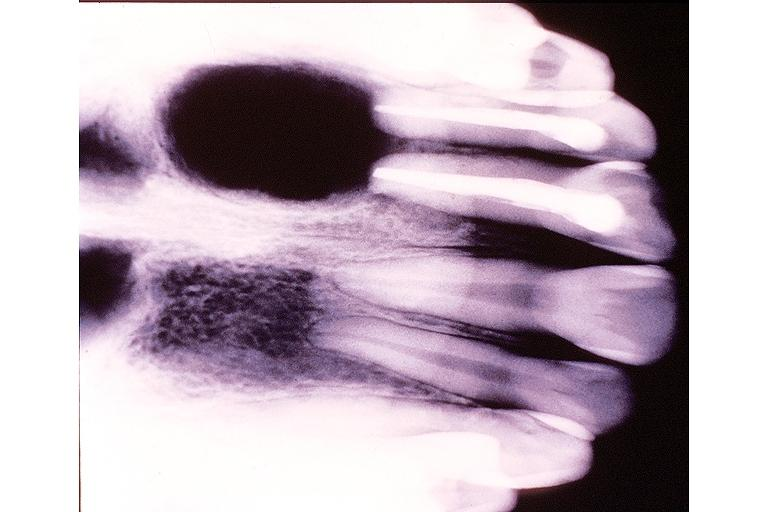s lesion of myocytolysis present?
Answer the question using a single word or phrase. No 